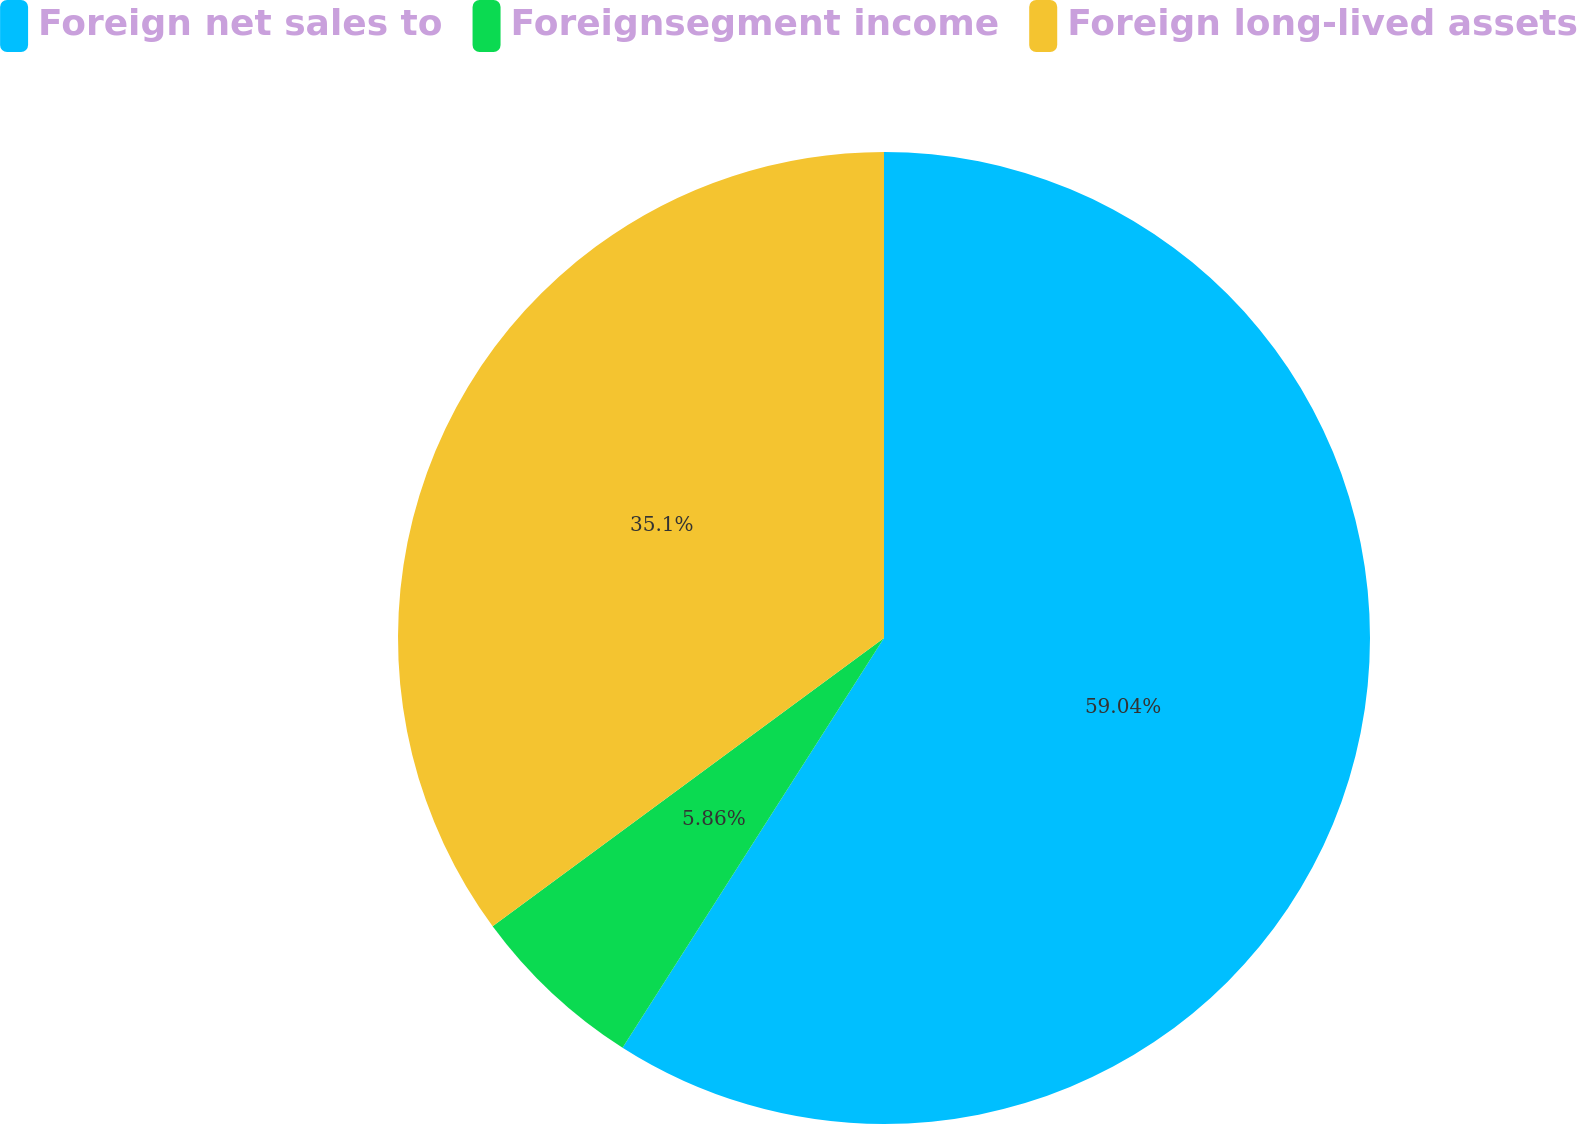Convert chart. <chart><loc_0><loc_0><loc_500><loc_500><pie_chart><fcel>Foreign net sales to<fcel>Foreignsegment income<fcel>Foreign long-lived assets<nl><fcel>59.04%<fcel>5.86%<fcel>35.1%<nl></chart> 